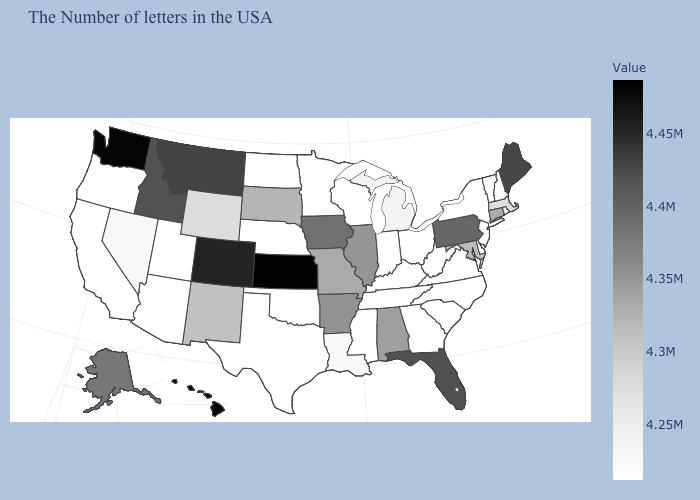Among the states that border Texas , which have the highest value?
Concise answer only. Arkansas. Which states have the highest value in the USA?
Short answer required. Hawaii. Which states have the highest value in the USA?
Keep it brief. Hawaii. 